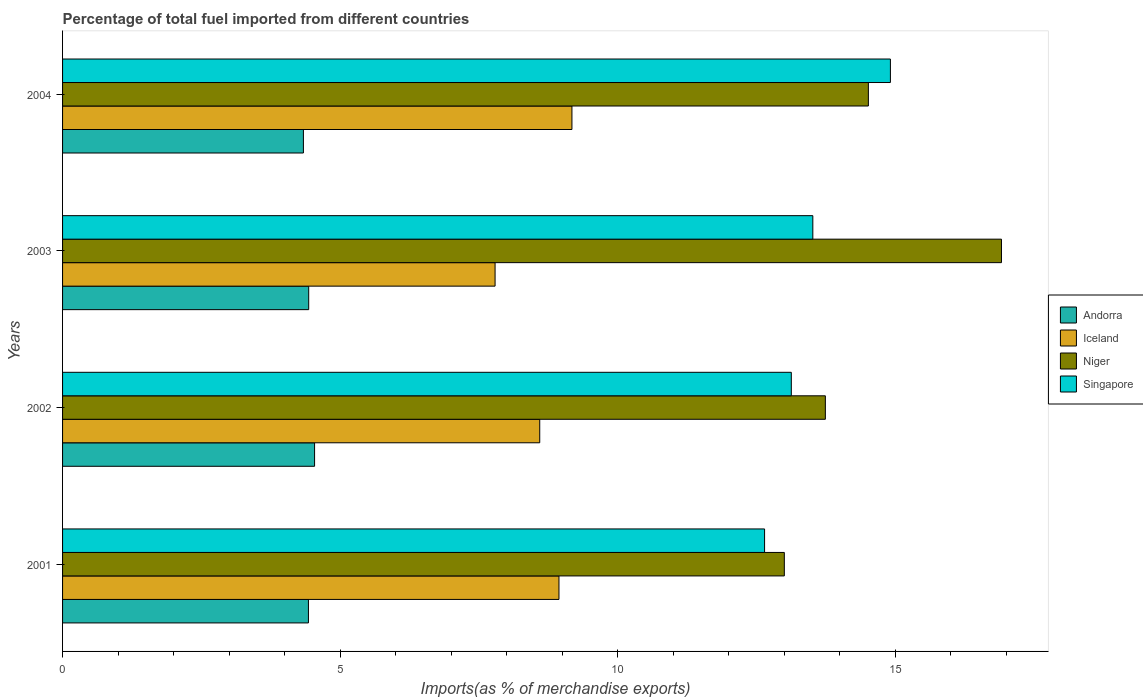How many different coloured bars are there?
Offer a terse response. 4. How many groups of bars are there?
Provide a succinct answer. 4. How many bars are there on the 2nd tick from the bottom?
Offer a terse response. 4. What is the percentage of imports to different countries in Singapore in 2004?
Ensure brevity in your answer.  14.91. Across all years, what is the maximum percentage of imports to different countries in Singapore?
Your answer should be very brief. 14.91. Across all years, what is the minimum percentage of imports to different countries in Niger?
Provide a succinct answer. 13. In which year was the percentage of imports to different countries in Iceland maximum?
Offer a very short reply. 2004. In which year was the percentage of imports to different countries in Niger minimum?
Provide a succinct answer. 2001. What is the total percentage of imports to different countries in Singapore in the graph?
Offer a very short reply. 54.21. What is the difference between the percentage of imports to different countries in Andorra in 2002 and that in 2003?
Ensure brevity in your answer.  0.11. What is the difference between the percentage of imports to different countries in Iceland in 2004 and the percentage of imports to different countries in Andorra in 2003?
Give a very brief answer. 4.74. What is the average percentage of imports to different countries in Iceland per year?
Give a very brief answer. 8.63. In the year 2004, what is the difference between the percentage of imports to different countries in Iceland and percentage of imports to different countries in Niger?
Offer a very short reply. -5.34. What is the ratio of the percentage of imports to different countries in Niger in 2001 to that in 2003?
Make the answer very short. 0.77. Is the percentage of imports to different countries in Niger in 2001 less than that in 2003?
Your response must be concise. Yes. What is the difference between the highest and the second highest percentage of imports to different countries in Andorra?
Provide a succinct answer. 0.11. What is the difference between the highest and the lowest percentage of imports to different countries in Singapore?
Offer a terse response. 2.27. Is the sum of the percentage of imports to different countries in Singapore in 2001 and 2004 greater than the maximum percentage of imports to different countries in Andorra across all years?
Offer a very short reply. Yes. Is it the case that in every year, the sum of the percentage of imports to different countries in Singapore and percentage of imports to different countries in Andorra is greater than the sum of percentage of imports to different countries in Niger and percentage of imports to different countries in Iceland?
Your answer should be very brief. No. What does the 2nd bar from the top in 2002 represents?
Your answer should be compact. Niger. What does the 1st bar from the bottom in 2003 represents?
Provide a succinct answer. Andorra. Is it the case that in every year, the sum of the percentage of imports to different countries in Singapore and percentage of imports to different countries in Andorra is greater than the percentage of imports to different countries in Niger?
Provide a short and direct response. Yes. How many bars are there?
Ensure brevity in your answer.  16. Are all the bars in the graph horizontal?
Ensure brevity in your answer.  Yes. How many years are there in the graph?
Your answer should be compact. 4. What is the difference between two consecutive major ticks on the X-axis?
Keep it short and to the point. 5. How many legend labels are there?
Ensure brevity in your answer.  4. How are the legend labels stacked?
Give a very brief answer. Vertical. What is the title of the graph?
Give a very brief answer. Percentage of total fuel imported from different countries. Does "France" appear as one of the legend labels in the graph?
Your response must be concise. No. What is the label or title of the X-axis?
Your response must be concise. Imports(as % of merchandise exports). What is the Imports(as % of merchandise exports) of Andorra in 2001?
Provide a succinct answer. 4.43. What is the Imports(as % of merchandise exports) in Iceland in 2001?
Give a very brief answer. 8.94. What is the Imports(as % of merchandise exports) in Niger in 2001?
Ensure brevity in your answer.  13. What is the Imports(as % of merchandise exports) of Singapore in 2001?
Make the answer very short. 12.65. What is the Imports(as % of merchandise exports) in Andorra in 2002?
Your response must be concise. 4.54. What is the Imports(as % of merchandise exports) of Iceland in 2002?
Your response must be concise. 8.6. What is the Imports(as % of merchandise exports) in Niger in 2002?
Give a very brief answer. 13.74. What is the Imports(as % of merchandise exports) of Singapore in 2002?
Ensure brevity in your answer.  13.13. What is the Imports(as % of merchandise exports) in Andorra in 2003?
Offer a very short reply. 4.43. What is the Imports(as % of merchandise exports) of Iceland in 2003?
Your answer should be very brief. 7.79. What is the Imports(as % of merchandise exports) in Niger in 2003?
Offer a very short reply. 16.91. What is the Imports(as % of merchandise exports) of Singapore in 2003?
Keep it short and to the point. 13.52. What is the Imports(as % of merchandise exports) of Andorra in 2004?
Your answer should be very brief. 4.34. What is the Imports(as % of merchandise exports) in Iceland in 2004?
Offer a terse response. 9.18. What is the Imports(as % of merchandise exports) of Niger in 2004?
Provide a succinct answer. 14.52. What is the Imports(as % of merchandise exports) in Singapore in 2004?
Keep it short and to the point. 14.91. Across all years, what is the maximum Imports(as % of merchandise exports) in Andorra?
Your answer should be very brief. 4.54. Across all years, what is the maximum Imports(as % of merchandise exports) of Iceland?
Keep it short and to the point. 9.18. Across all years, what is the maximum Imports(as % of merchandise exports) in Niger?
Offer a terse response. 16.91. Across all years, what is the maximum Imports(as % of merchandise exports) in Singapore?
Offer a terse response. 14.91. Across all years, what is the minimum Imports(as % of merchandise exports) of Andorra?
Your answer should be compact. 4.34. Across all years, what is the minimum Imports(as % of merchandise exports) of Iceland?
Offer a terse response. 7.79. Across all years, what is the minimum Imports(as % of merchandise exports) in Niger?
Your answer should be compact. 13. Across all years, what is the minimum Imports(as % of merchandise exports) in Singapore?
Make the answer very short. 12.65. What is the total Imports(as % of merchandise exports) of Andorra in the graph?
Provide a succinct answer. 17.74. What is the total Imports(as % of merchandise exports) of Iceland in the graph?
Your answer should be very brief. 34.51. What is the total Imports(as % of merchandise exports) in Niger in the graph?
Your answer should be very brief. 58.18. What is the total Imports(as % of merchandise exports) in Singapore in the graph?
Offer a very short reply. 54.21. What is the difference between the Imports(as % of merchandise exports) of Andorra in 2001 and that in 2002?
Your answer should be very brief. -0.11. What is the difference between the Imports(as % of merchandise exports) of Iceland in 2001 and that in 2002?
Make the answer very short. 0.35. What is the difference between the Imports(as % of merchandise exports) in Niger in 2001 and that in 2002?
Ensure brevity in your answer.  -0.74. What is the difference between the Imports(as % of merchandise exports) of Singapore in 2001 and that in 2002?
Offer a terse response. -0.48. What is the difference between the Imports(as % of merchandise exports) of Andorra in 2001 and that in 2003?
Provide a short and direct response. -0. What is the difference between the Imports(as % of merchandise exports) in Iceland in 2001 and that in 2003?
Give a very brief answer. 1.15. What is the difference between the Imports(as % of merchandise exports) of Niger in 2001 and that in 2003?
Give a very brief answer. -3.91. What is the difference between the Imports(as % of merchandise exports) of Singapore in 2001 and that in 2003?
Your answer should be compact. -0.87. What is the difference between the Imports(as % of merchandise exports) of Andorra in 2001 and that in 2004?
Give a very brief answer. 0.09. What is the difference between the Imports(as % of merchandise exports) of Iceland in 2001 and that in 2004?
Offer a very short reply. -0.23. What is the difference between the Imports(as % of merchandise exports) of Niger in 2001 and that in 2004?
Ensure brevity in your answer.  -1.51. What is the difference between the Imports(as % of merchandise exports) in Singapore in 2001 and that in 2004?
Offer a very short reply. -2.27. What is the difference between the Imports(as % of merchandise exports) in Andorra in 2002 and that in 2003?
Ensure brevity in your answer.  0.11. What is the difference between the Imports(as % of merchandise exports) of Iceland in 2002 and that in 2003?
Offer a terse response. 0.8. What is the difference between the Imports(as % of merchandise exports) of Niger in 2002 and that in 2003?
Your answer should be compact. -3.17. What is the difference between the Imports(as % of merchandise exports) in Singapore in 2002 and that in 2003?
Your response must be concise. -0.39. What is the difference between the Imports(as % of merchandise exports) in Andorra in 2002 and that in 2004?
Offer a very short reply. 0.2. What is the difference between the Imports(as % of merchandise exports) in Iceland in 2002 and that in 2004?
Your response must be concise. -0.58. What is the difference between the Imports(as % of merchandise exports) of Niger in 2002 and that in 2004?
Your answer should be compact. -0.78. What is the difference between the Imports(as % of merchandise exports) of Singapore in 2002 and that in 2004?
Provide a short and direct response. -1.79. What is the difference between the Imports(as % of merchandise exports) of Andorra in 2003 and that in 2004?
Provide a succinct answer. 0.1. What is the difference between the Imports(as % of merchandise exports) of Iceland in 2003 and that in 2004?
Provide a succinct answer. -1.38. What is the difference between the Imports(as % of merchandise exports) in Niger in 2003 and that in 2004?
Give a very brief answer. 2.4. What is the difference between the Imports(as % of merchandise exports) in Singapore in 2003 and that in 2004?
Provide a succinct answer. -1.4. What is the difference between the Imports(as % of merchandise exports) of Andorra in 2001 and the Imports(as % of merchandise exports) of Iceland in 2002?
Keep it short and to the point. -4.17. What is the difference between the Imports(as % of merchandise exports) of Andorra in 2001 and the Imports(as % of merchandise exports) of Niger in 2002?
Keep it short and to the point. -9.31. What is the difference between the Imports(as % of merchandise exports) in Andorra in 2001 and the Imports(as % of merchandise exports) in Singapore in 2002?
Ensure brevity in your answer.  -8.7. What is the difference between the Imports(as % of merchandise exports) of Iceland in 2001 and the Imports(as % of merchandise exports) of Niger in 2002?
Offer a terse response. -4.8. What is the difference between the Imports(as % of merchandise exports) in Iceland in 2001 and the Imports(as % of merchandise exports) in Singapore in 2002?
Your response must be concise. -4.19. What is the difference between the Imports(as % of merchandise exports) of Niger in 2001 and the Imports(as % of merchandise exports) of Singapore in 2002?
Give a very brief answer. -0.13. What is the difference between the Imports(as % of merchandise exports) of Andorra in 2001 and the Imports(as % of merchandise exports) of Iceland in 2003?
Make the answer very short. -3.36. What is the difference between the Imports(as % of merchandise exports) of Andorra in 2001 and the Imports(as % of merchandise exports) of Niger in 2003?
Make the answer very short. -12.49. What is the difference between the Imports(as % of merchandise exports) of Andorra in 2001 and the Imports(as % of merchandise exports) of Singapore in 2003?
Your response must be concise. -9.09. What is the difference between the Imports(as % of merchandise exports) of Iceland in 2001 and the Imports(as % of merchandise exports) of Niger in 2003?
Offer a terse response. -7.97. What is the difference between the Imports(as % of merchandise exports) of Iceland in 2001 and the Imports(as % of merchandise exports) of Singapore in 2003?
Your answer should be compact. -4.57. What is the difference between the Imports(as % of merchandise exports) of Niger in 2001 and the Imports(as % of merchandise exports) of Singapore in 2003?
Offer a very short reply. -0.51. What is the difference between the Imports(as % of merchandise exports) of Andorra in 2001 and the Imports(as % of merchandise exports) of Iceland in 2004?
Your response must be concise. -4.75. What is the difference between the Imports(as % of merchandise exports) in Andorra in 2001 and the Imports(as % of merchandise exports) in Niger in 2004?
Ensure brevity in your answer.  -10.09. What is the difference between the Imports(as % of merchandise exports) of Andorra in 2001 and the Imports(as % of merchandise exports) of Singapore in 2004?
Provide a succinct answer. -10.48. What is the difference between the Imports(as % of merchandise exports) of Iceland in 2001 and the Imports(as % of merchandise exports) of Niger in 2004?
Ensure brevity in your answer.  -5.57. What is the difference between the Imports(as % of merchandise exports) of Iceland in 2001 and the Imports(as % of merchandise exports) of Singapore in 2004?
Make the answer very short. -5.97. What is the difference between the Imports(as % of merchandise exports) of Niger in 2001 and the Imports(as % of merchandise exports) of Singapore in 2004?
Offer a terse response. -1.91. What is the difference between the Imports(as % of merchandise exports) of Andorra in 2002 and the Imports(as % of merchandise exports) of Iceland in 2003?
Provide a succinct answer. -3.25. What is the difference between the Imports(as % of merchandise exports) in Andorra in 2002 and the Imports(as % of merchandise exports) in Niger in 2003?
Offer a terse response. -12.37. What is the difference between the Imports(as % of merchandise exports) of Andorra in 2002 and the Imports(as % of merchandise exports) of Singapore in 2003?
Ensure brevity in your answer.  -8.98. What is the difference between the Imports(as % of merchandise exports) of Iceland in 2002 and the Imports(as % of merchandise exports) of Niger in 2003?
Keep it short and to the point. -8.32. What is the difference between the Imports(as % of merchandise exports) in Iceland in 2002 and the Imports(as % of merchandise exports) in Singapore in 2003?
Your answer should be very brief. -4.92. What is the difference between the Imports(as % of merchandise exports) in Niger in 2002 and the Imports(as % of merchandise exports) in Singapore in 2003?
Your answer should be very brief. 0.23. What is the difference between the Imports(as % of merchandise exports) of Andorra in 2002 and the Imports(as % of merchandise exports) of Iceland in 2004?
Provide a succinct answer. -4.64. What is the difference between the Imports(as % of merchandise exports) of Andorra in 2002 and the Imports(as % of merchandise exports) of Niger in 2004?
Keep it short and to the point. -9.98. What is the difference between the Imports(as % of merchandise exports) in Andorra in 2002 and the Imports(as % of merchandise exports) in Singapore in 2004?
Give a very brief answer. -10.37. What is the difference between the Imports(as % of merchandise exports) in Iceland in 2002 and the Imports(as % of merchandise exports) in Niger in 2004?
Your answer should be very brief. -5.92. What is the difference between the Imports(as % of merchandise exports) in Iceland in 2002 and the Imports(as % of merchandise exports) in Singapore in 2004?
Keep it short and to the point. -6.32. What is the difference between the Imports(as % of merchandise exports) of Niger in 2002 and the Imports(as % of merchandise exports) of Singapore in 2004?
Give a very brief answer. -1.17. What is the difference between the Imports(as % of merchandise exports) of Andorra in 2003 and the Imports(as % of merchandise exports) of Iceland in 2004?
Provide a succinct answer. -4.74. What is the difference between the Imports(as % of merchandise exports) in Andorra in 2003 and the Imports(as % of merchandise exports) in Niger in 2004?
Provide a succinct answer. -10.08. What is the difference between the Imports(as % of merchandise exports) in Andorra in 2003 and the Imports(as % of merchandise exports) in Singapore in 2004?
Provide a succinct answer. -10.48. What is the difference between the Imports(as % of merchandise exports) in Iceland in 2003 and the Imports(as % of merchandise exports) in Niger in 2004?
Make the answer very short. -6.73. What is the difference between the Imports(as % of merchandise exports) of Iceland in 2003 and the Imports(as % of merchandise exports) of Singapore in 2004?
Provide a short and direct response. -7.12. What is the difference between the Imports(as % of merchandise exports) in Niger in 2003 and the Imports(as % of merchandise exports) in Singapore in 2004?
Make the answer very short. 2. What is the average Imports(as % of merchandise exports) in Andorra per year?
Keep it short and to the point. 4.44. What is the average Imports(as % of merchandise exports) of Iceland per year?
Keep it short and to the point. 8.63. What is the average Imports(as % of merchandise exports) of Niger per year?
Provide a succinct answer. 14.54. What is the average Imports(as % of merchandise exports) of Singapore per year?
Provide a short and direct response. 13.55. In the year 2001, what is the difference between the Imports(as % of merchandise exports) in Andorra and Imports(as % of merchandise exports) in Iceland?
Your answer should be compact. -4.51. In the year 2001, what is the difference between the Imports(as % of merchandise exports) of Andorra and Imports(as % of merchandise exports) of Niger?
Offer a terse response. -8.57. In the year 2001, what is the difference between the Imports(as % of merchandise exports) in Andorra and Imports(as % of merchandise exports) in Singapore?
Provide a short and direct response. -8.22. In the year 2001, what is the difference between the Imports(as % of merchandise exports) of Iceland and Imports(as % of merchandise exports) of Niger?
Give a very brief answer. -4.06. In the year 2001, what is the difference between the Imports(as % of merchandise exports) of Iceland and Imports(as % of merchandise exports) of Singapore?
Give a very brief answer. -3.7. In the year 2001, what is the difference between the Imports(as % of merchandise exports) in Niger and Imports(as % of merchandise exports) in Singapore?
Your answer should be compact. 0.36. In the year 2002, what is the difference between the Imports(as % of merchandise exports) of Andorra and Imports(as % of merchandise exports) of Iceland?
Make the answer very short. -4.06. In the year 2002, what is the difference between the Imports(as % of merchandise exports) of Andorra and Imports(as % of merchandise exports) of Niger?
Provide a succinct answer. -9.2. In the year 2002, what is the difference between the Imports(as % of merchandise exports) of Andorra and Imports(as % of merchandise exports) of Singapore?
Ensure brevity in your answer.  -8.59. In the year 2002, what is the difference between the Imports(as % of merchandise exports) in Iceland and Imports(as % of merchandise exports) in Niger?
Your response must be concise. -5.15. In the year 2002, what is the difference between the Imports(as % of merchandise exports) in Iceland and Imports(as % of merchandise exports) in Singapore?
Offer a terse response. -4.53. In the year 2002, what is the difference between the Imports(as % of merchandise exports) of Niger and Imports(as % of merchandise exports) of Singapore?
Offer a terse response. 0.61. In the year 2003, what is the difference between the Imports(as % of merchandise exports) in Andorra and Imports(as % of merchandise exports) in Iceland?
Your response must be concise. -3.36. In the year 2003, what is the difference between the Imports(as % of merchandise exports) in Andorra and Imports(as % of merchandise exports) in Niger?
Provide a short and direct response. -12.48. In the year 2003, what is the difference between the Imports(as % of merchandise exports) in Andorra and Imports(as % of merchandise exports) in Singapore?
Provide a succinct answer. -9.08. In the year 2003, what is the difference between the Imports(as % of merchandise exports) of Iceland and Imports(as % of merchandise exports) of Niger?
Offer a terse response. -9.12. In the year 2003, what is the difference between the Imports(as % of merchandise exports) in Iceland and Imports(as % of merchandise exports) in Singapore?
Keep it short and to the point. -5.72. In the year 2003, what is the difference between the Imports(as % of merchandise exports) in Niger and Imports(as % of merchandise exports) in Singapore?
Provide a succinct answer. 3.4. In the year 2004, what is the difference between the Imports(as % of merchandise exports) of Andorra and Imports(as % of merchandise exports) of Iceland?
Your answer should be very brief. -4.84. In the year 2004, what is the difference between the Imports(as % of merchandise exports) of Andorra and Imports(as % of merchandise exports) of Niger?
Keep it short and to the point. -10.18. In the year 2004, what is the difference between the Imports(as % of merchandise exports) in Andorra and Imports(as % of merchandise exports) in Singapore?
Ensure brevity in your answer.  -10.58. In the year 2004, what is the difference between the Imports(as % of merchandise exports) of Iceland and Imports(as % of merchandise exports) of Niger?
Give a very brief answer. -5.34. In the year 2004, what is the difference between the Imports(as % of merchandise exports) of Iceland and Imports(as % of merchandise exports) of Singapore?
Your response must be concise. -5.74. In the year 2004, what is the difference between the Imports(as % of merchandise exports) in Niger and Imports(as % of merchandise exports) in Singapore?
Provide a succinct answer. -0.4. What is the ratio of the Imports(as % of merchandise exports) in Andorra in 2001 to that in 2002?
Give a very brief answer. 0.98. What is the ratio of the Imports(as % of merchandise exports) of Iceland in 2001 to that in 2002?
Offer a very short reply. 1.04. What is the ratio of the Imports(as % of merchandise exports) of Niger in 2001 to that in 2002?
Keep it short and to the point. 0.95. What is the ratio of the Imports(as % of merchandise exports) of Singapore in 2001 to that in 2002?
Your answer should be compact. 0.96. What is the ratio of the Imports(as % of merchandise exports) in Andorra in 2001 to that in 2003?
Offer a terse response. 1. What is the ratio of the Imports(as % of merchandise exports) of Iceland in 2001 to that in 2003?
Keep it short and to the point. 1.15. What is the ratio of the Imports(as % of merchandise exports) of Niger in 2001 to that in 2003?
Ensure brevity in your answer.  0.77. What is the ratio of the Imports(as % of merchandise exports) in Singapore in 2001 to that in 2003?
Offer a very short reply. 0.94. What is the ratio of the Imports(as % of merchandise exports) of Andorra in 2001 to that in 2004?
Keep it short and to the point. 1.02. What is the ratio of the Imports(as % of merchandise exports) in Iceland in 2001 to that in 2004?
Your answer should be very brief. 0.97. What is the ratio of the Imports(as % of merchandise exports) in Niger in 2001 to that in 2004?
Make the answer very short. 0.9. What is the ratio of the Imports(as % of merchandise exports) in Singapore in 2001 to that in 2004?
Your answer should be very brief. 0.85. What is the ratio of the Imports(as % of merchandise exports) in Andorra in 2002 to that in 2003?
Your answer should be compact. 1.02. What is the ratio of the Imports(as % of merchandise exports) in Iceland in 2002 to that in 2003?
Your response must be concise. 1.1. What is the ratio of the Imports(as % of merchandise exports) of Niger in 2002 to that in 2003?
Offer a terse response. 0.81. What is the ratio of the Imports(as % of merchandise exports) of Singapore in 2002 to that in 2003?
Offer a very short reply. 0.97. What is the ratio of the Imports(as % of merchandise exports) of Andorra in 2002 to that in 2004?
Offer a terse response. 1.05. What is the ratio of the Imports(as % of merchandise exports) in Iceland in 2002 to that in 2004?
Offer a terse response. 0.94. What is the ratio of the Imports(as % of merchandise exports) in Niger in 2002 to that in 2004?
Your answer should be compact. 0.95. What is the ratio of the Imports(as % of merchandise exports) in Singapore in 2002 to that in 2004?
Ensure brevity in your answer.  0.88. What is the ratio of the Imports(as % of merchandise exports) of Andorra in 2003 to that in 2004?
Your answer should be compact. 1.02. What is the ratio of the Imports(as % of merchandise exports) of Iceland in 2003 to that in 2004?
Provide a succinct answer. 0.85. What is the ratio of the Imports(as % of merchandise exports) of Niger in 2003 to that in 2004?
Offer a terse response. 1.17. What is the ratio of the Imports(as % of merchandise exports) of Singapore in 2003 to that in 2004?
Offer a terse response. 0.91. What is the difference between the highest and the second highest Imports(as % of merchandise exports) of Andorra?
Provide a short and direct response. 0.11. What is the difference between the highest and the second highest Imports(as % of merchandise exports) in Iceland?
Keep it short and to the point. 0.23. What is the difference between the highest and the second highest Imports(as % of merchandise exports) in Niger?
Ensure brevity in your answer.  2.4. What is the difference between the highest and the second highest Imports(as % of merchandise exports) of Singapore?
Ensure brevity in your answer.  1.4. What is the difference between the highest and the lowest Imports(as % of merchandise exports) in Andorra?
Ensure brevity in your answer.  0.2. What is the difference between the highest and the lowest Imports(as % of merchandise exports) in Iceland?
Offer a terse response. 1.38. What is the difference between the highest and the lowest Imports(as % of merchandise exports) of Niger?
Ensure brevity in your answer.  3.91. What is the difference between the highest and the lowest Imports(as % of merchandise exports) in Singapore?
Offer a very short reply. 2.27. 